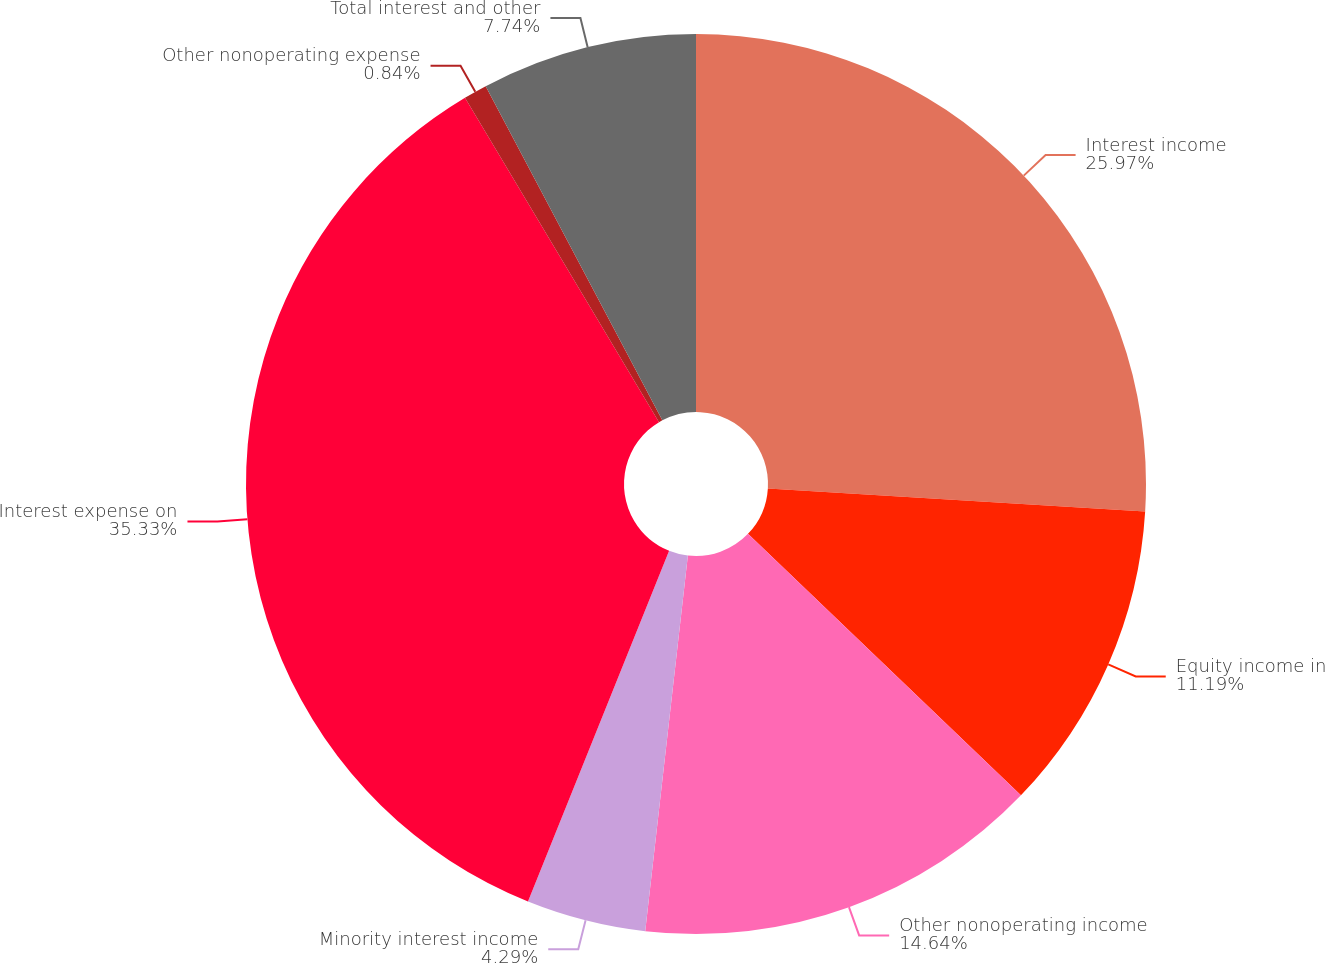Convert chart. <chart><loc_0><loc_0><loc_500><loc_500><pie_chart><fcel>Interest income<fcel>Equity income in<fcel>Other nonoperating income<fcel>Minority interest income<fcel>Interest expense on<fcel>Other nonoperating expense<fcel>Total interest and other<nl><fcel>25.97%<fcel>11.19%<fcel>14.64%<fcel>4.29%<fcel>35.33%<fcel>0.84%<fcel>7.74%<nl></chart> 